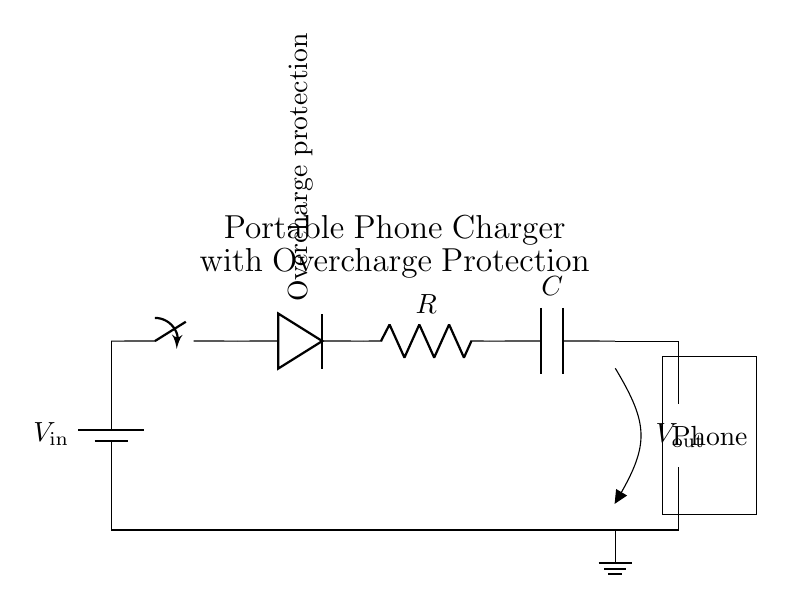What is the input voltage of this circuit? The input voltage is indicated by the symbol \( V_{\text{in}} \), which is the potential supplied by the battery.
Answer: \( V_{\text{in}} \) What component provides overcharge protection? The diode labeled as "Overcharge protection" in the circuit diagram allows current to flow in one direction, preventing reverse current that could damage the battery.
Answer: Diode What is the role of the resistor in this circuit? The resistor, represented by \( R \), can limit the amount of current flowing through the circuit, protecting the other components and ensuring they operate within their safe limits.
Answer: Current limiting What is the purpose of the capacitor in this circuit? The capacitor, labeled \( C \), is used to store energy and smooth out the voltage output, providing a stable voltage to the connected phone.
Answer: Energy storage How many main components are in the circuit? The major components in the series circuit include the battery, switch, diode, resistor, and capacitor, which makes it a total of five main components.
Answer: Five What happens if the switch is open? If the switch is open, it breaks the circuit, preventing current from flowing through to the other components and, consequently, to the phone, effectively stopping the charging process.
Answer: No current flows What voltage is expected at the output? The output voltage, shown as \( V_{\text{out}} \), represents the voltage available to charge the phone, which is typically lower than the input voltage due to the components in the circuit.
Answer: \( V_{\text{out}} \) 